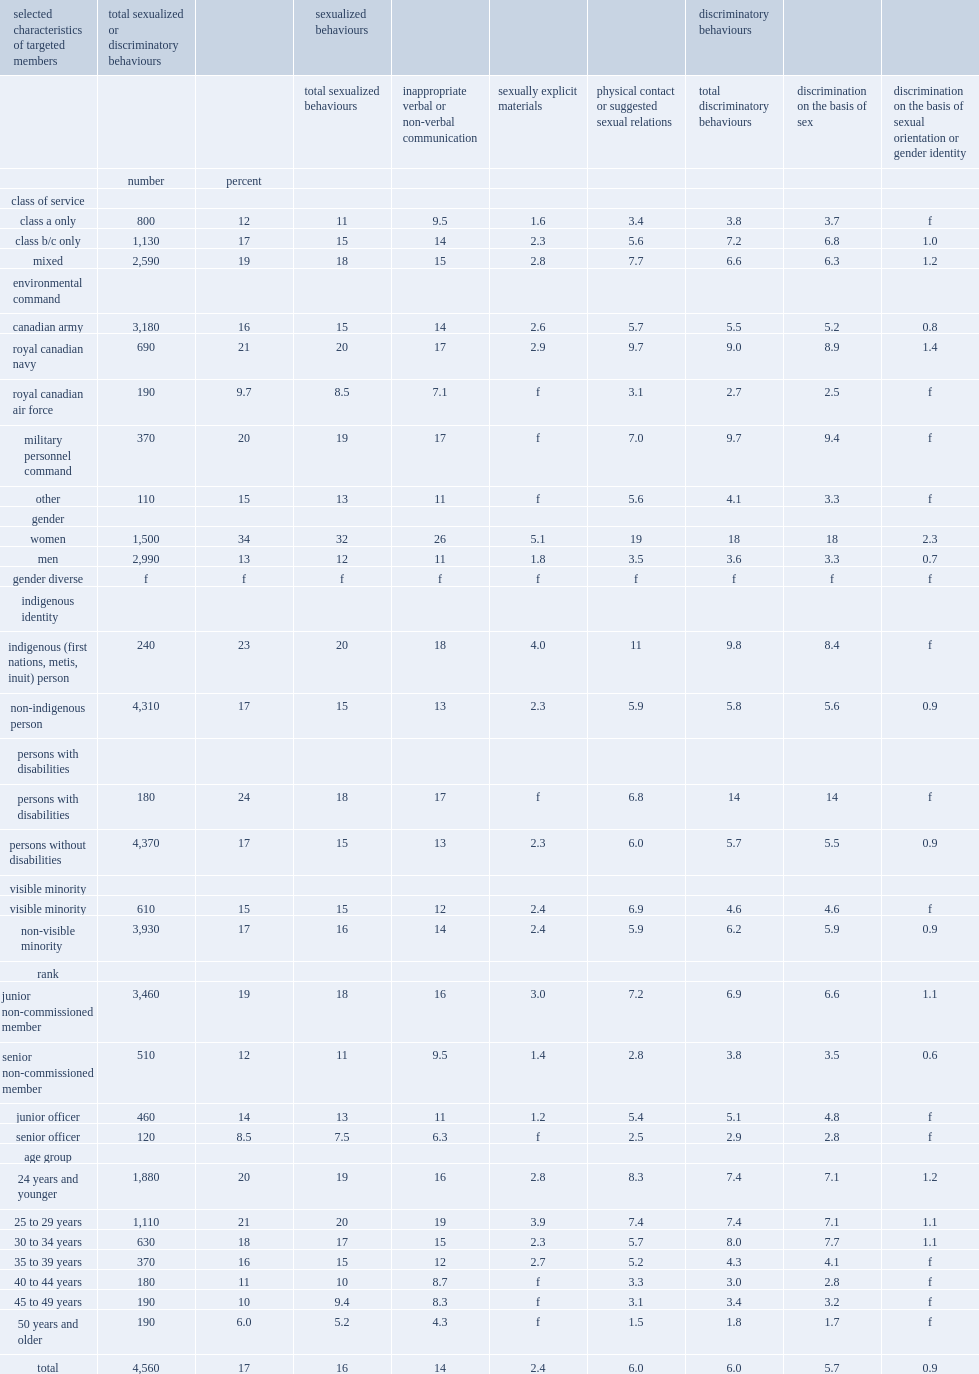What is the percentage of individuals indicating that they have been personally targeted by at least one sexual or discriminatory behaviour? 17.0. How many individuals indicate that they had been personally targeted by at least one sexual or discriminatory behaviour? 4560.0. What is the percentage of reservists experiencing targeted sexualized behaviours? 16.0. What is the percentage of members experiencing inappropriate verbal or non-verbal communication? 14.0. How many times are women serving in the primary reserve than their male counterparts to have experienced targeted sexualized or discriminatory behaviours? 2.615385. What is the percentage of women reporting inappropriate verbal or non-verbal communication? 26.0. What is the percentage of men reporting inappropriate verbal or non-verbal communication? 11.0. What is the percentage of women reporting unwanted physical contact or suggested sexual relation? 19.0. What is the percentage of men reporting unwanted physical contact or suggested sexual relation? 3.5. What is the percentage of women experiencing sexually explicit materials? 5.1. What is the percentage of men experiencing sexually explicit materials? 1.8. How many times are the percentage of female members than their male peers to report having been the target of total discrimination behaviours. 5. Which indigenous identity is more likely to experience total sexualized behaviours, indigenous or non-indigenous? Indigenous (first nations, metis, inuit) person. Which indigenous identity is more likely to experience total discrimination behaviours, indigenous or non-indigenous? Indigenous (first nations, metis, inuit) person. Which group of people is less likely to have experienced total discriminatory behaviours, members of a visible minority or not members of this group? Visible minority. Which class of service reports the lowest prevalence of targeted sexual behaviours? Class a only. Which class of service reports the lowest prevalence of targeted discriminatory behaviours? Class a only. 